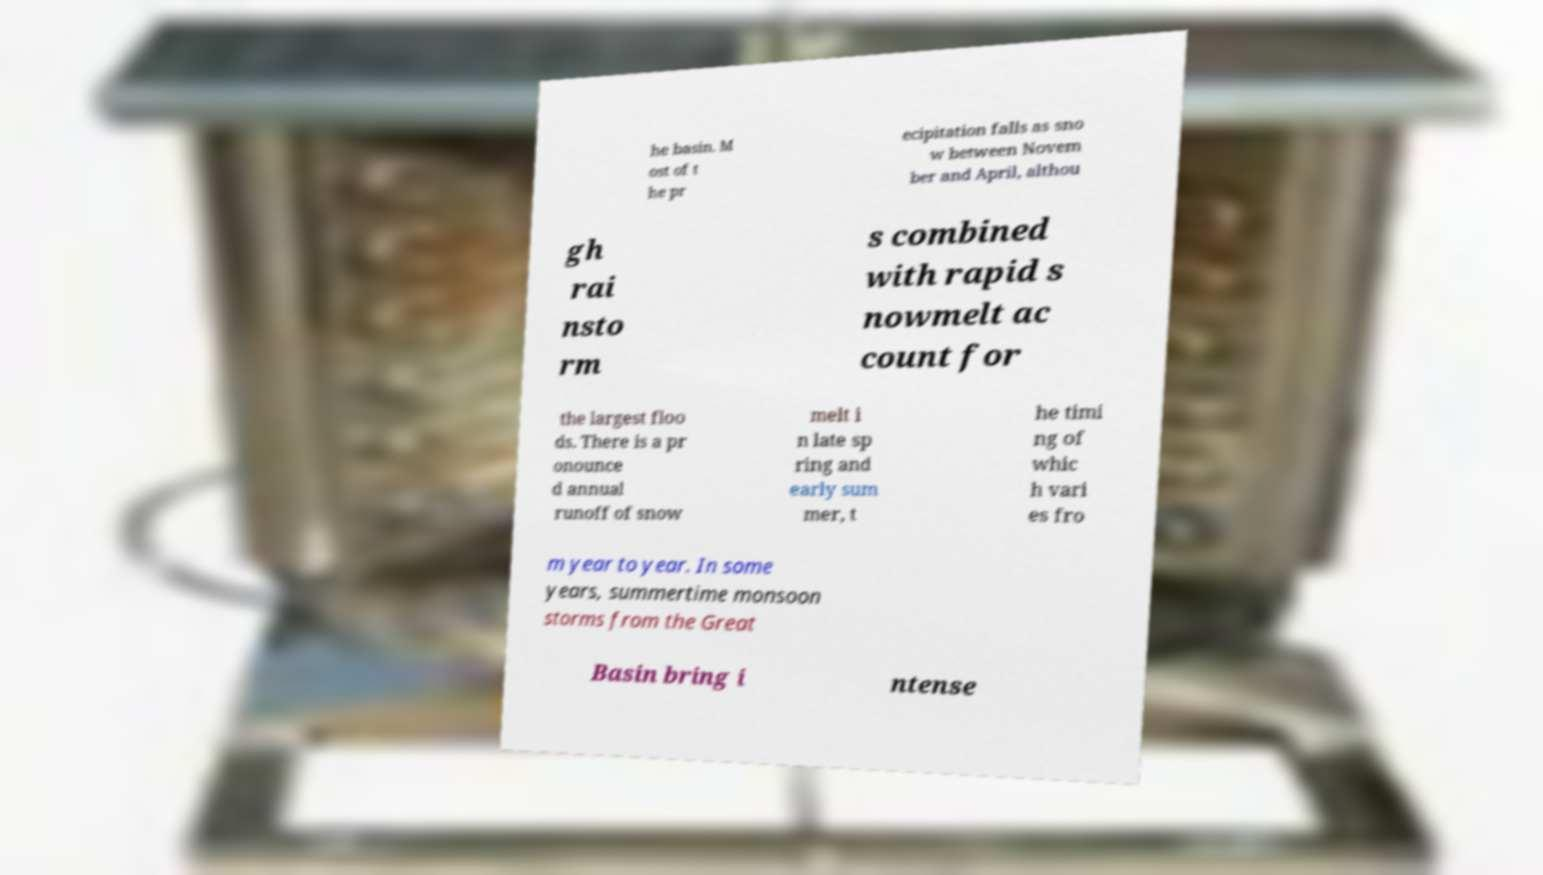What messages or text are displayed in this image? I need them in a readable, typed format. he basin. M ost of t he pr ecipitation falls as sno w between Novem ber and April, althou gh rai nsto rm s combined with rapid s nowmelt ac count for the largest floo ds. There is a pr onounce d annual runoff of snow melt i n late sp ring and early sum mer, t he timi ng of whic h vari es fro m year to year. In some years, summertime monsoon storms from the Great Basin bring i ntense 